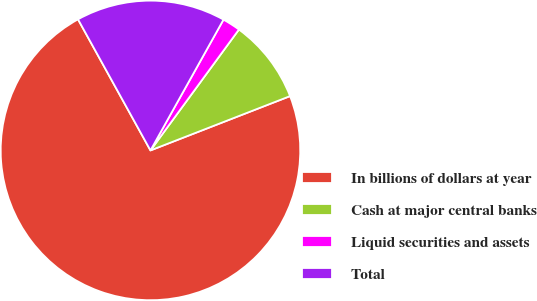Convert chart to OTSL. <chart><loc_0><loc_0><loc_500><loc_500><pie_chart><fcel>In billions of dollars at year<fcel>Cash at major central banks<fcel>Liquid securities and assets<fcel>Total<nl><fcel>72.87%<fcel>9.04%<fcel>1.95%<fcel>16.14%<nl></chart> 